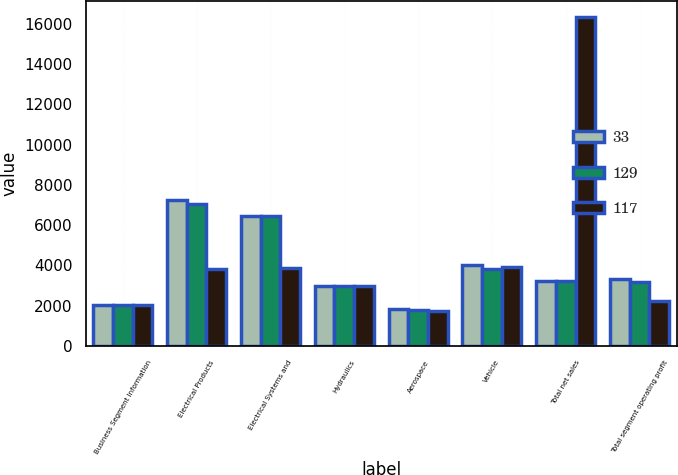Convert chart to OTSL. <chart><loc_0><loc_0><loc_500><loc_500><stacked_bar_chart><ecel><fcel>Business Segment Information<fcel>Electrical Products<fcel>Electrical Systems and<fcel>Hydraulics<fcel>Aerospace<fcel>Vehicle<fcel>Total net sales<fcel>Total segment operating profit<nl><fcel>33<fcel>2014<fcel>7254<fcel>6457<fcel>2975<fcel>1860<fcel>4006<fcel>3245<fcel>3312<nl><fcel>129<fcel>2013<fcel>7026<fcel>6430<fcel>2981<fcel>1774<fcel>3835<fcel>3245<fcel>3178<nl><fcel>117<fcel>2012<fcel>3846<fcel>3872<fcel>2960<fcel>1719<fcel>3914<fcel>16311<fcel>2216<nl></chart> 